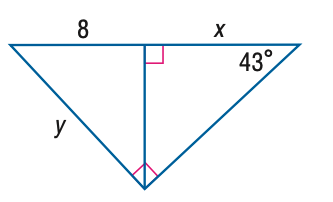Answer the mathemtical geometry problem and directly provide the correct option letter.
Question: Find x. Round to the nearest tenth.
Choices: A: 4.6 B: 8.0 C: 9.2 D: 17.2 C 